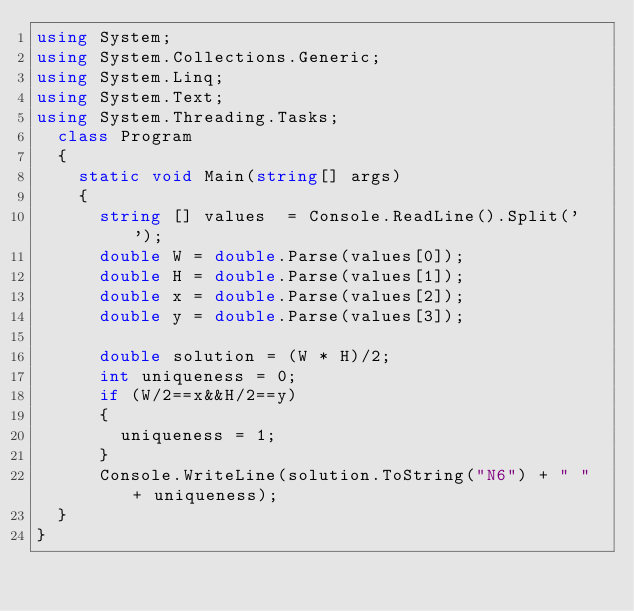Convert code to text. <code><loc_0><loc_0><loc_500><loc_500><_C#_>using System;
using System.Collections.Generic;
using System.Linq;
using System.Text;
using System.Threading.Tasks;
	class Program
	{
		static void Main(string[] args)
		{
			string [] values  = Console.ReadLine().Split(' ');
			double W = double.Parse(values[0]);
			double H = double.Parse(values[1]);
			double x = double.Parse(values[2]);
			double y = double.Parse(values[3]);

			double solution = (W * H)/2;
			int uniqueness = 0;
			if (W/2==x&&H/2==y)
			{
				uniqueness = 1;
			}
			Console.WriteLine(solution.ToString("N6") + " " + uniqueness);
	}
}
</code> 